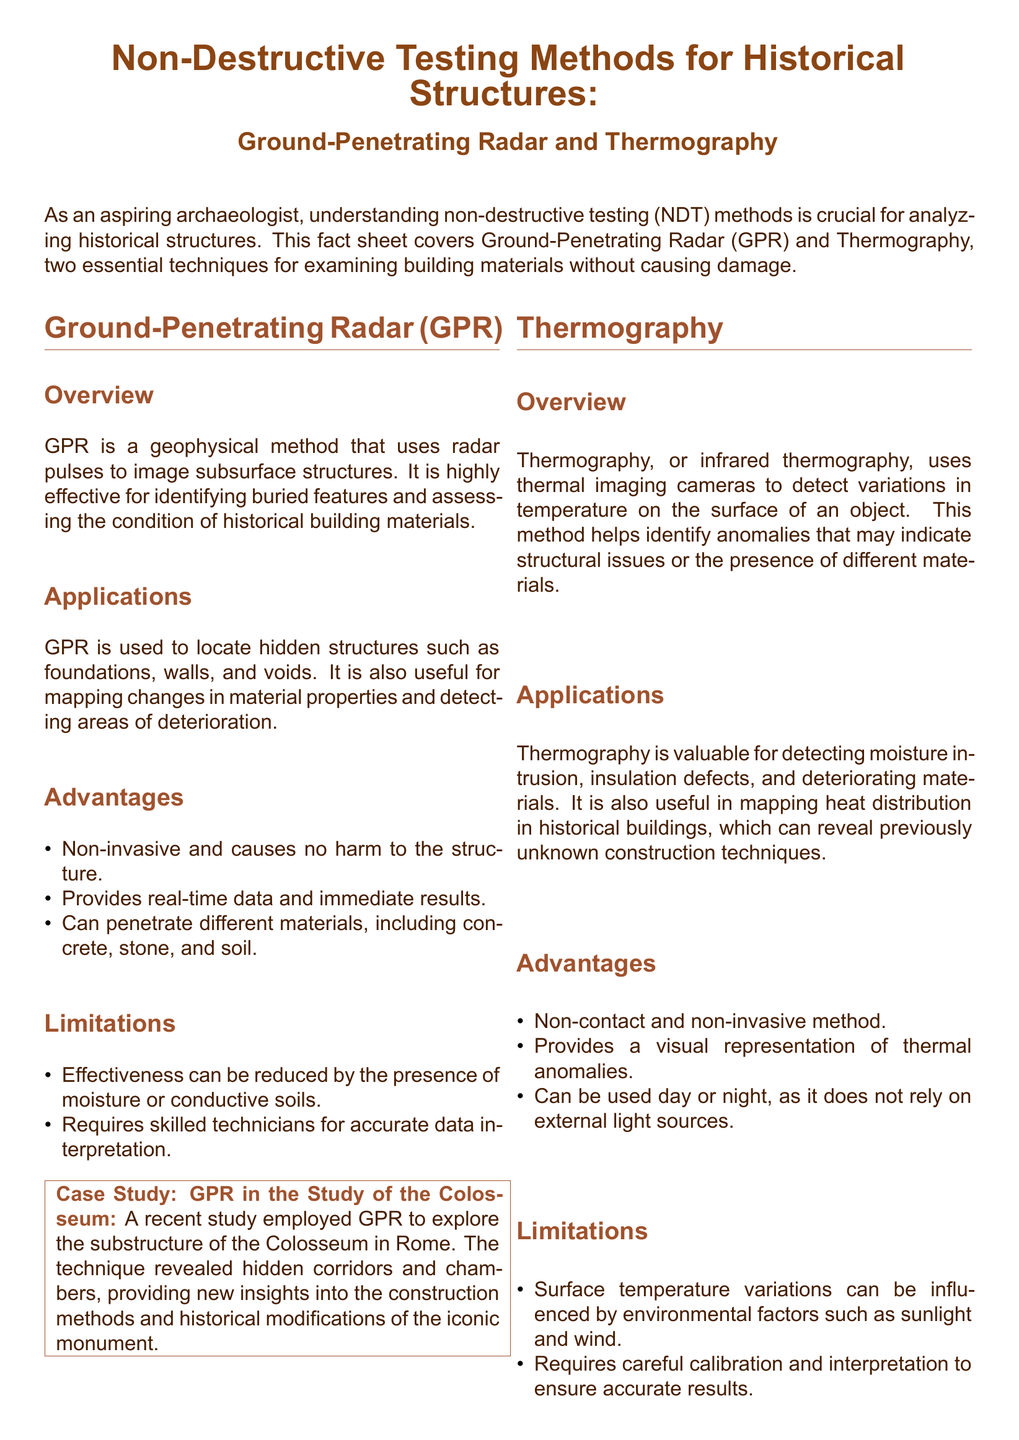What is the primary purpose of GPR? GPR is used to image subsurface structures, making it effective for identifying buried features and assessing the condition of historical building materials.
Answer: To image subsurface structures What technique is used for detecting variations in temperature? The document describes thermography, which utilizes thermal imaging cameras to detect temperature variations on surfaces.
Answer: Thermography What is one advantage of using GPR? One advantage mentioned is that GPR is non-invasive and causes no harm to the structure.
Answer: Non-invasive What limitation affects the effectiveness of GPR? The effectiveness of GPR can be reduced by the presence of moisture or conductive soils.
Answer: Moisture or conductive soils What does thermography help identify in historical buildings? Thermography is valuable for detecting moisture intrusion, insulation defects, and deteriorating materials.
Answer: Moisture intrusion What major feature was revealed in the Colosseum using GPR? GPR revealed hidden corridors and chambers, aiding in understanding the construction methods and historical modifications.
Answer: Hidden corridors and chambers Which historical structure was analyzed using thermography? The Tower of London was studied using thermographic analysis to identify areas of moisture ingress.
Answer: Tower of London What kind of representation does thermography provide? Thermography provides a visual representation of thermal anomalies.
Answer: Visual representation of thermal anomalies What is a condition that affects thermography results? Surface temperature variations can be influenced by environmental factors such as sunlight and wind.
Answer: Environmental factors like sunlight and wind 